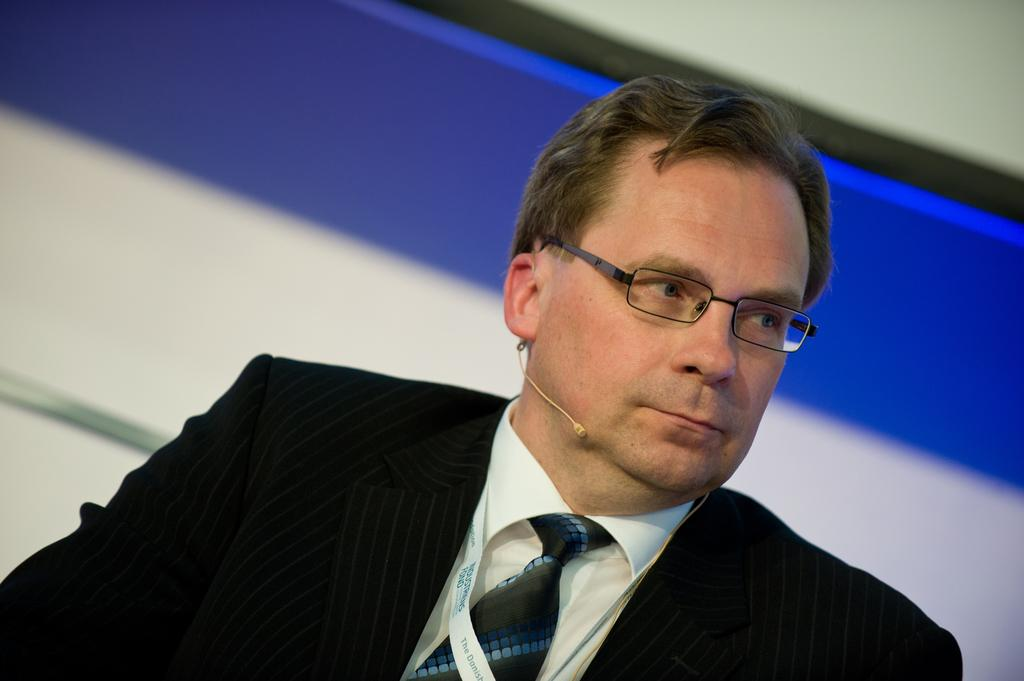Where was the image taken? The image is taken indoors. What can be seen in the background of the image? There is a wall in the background of the image. Who is the main subject in the image? There is a man in the middle of the image. What is the man wearing? The man is wearing a suit, a shirt, a tie, and spectacles. How many people are smiling in the crowd in the image? There is no crowd or smiling people present in the image; it features a man wearing a suit, shirt, tie, and spectacles indoors. 